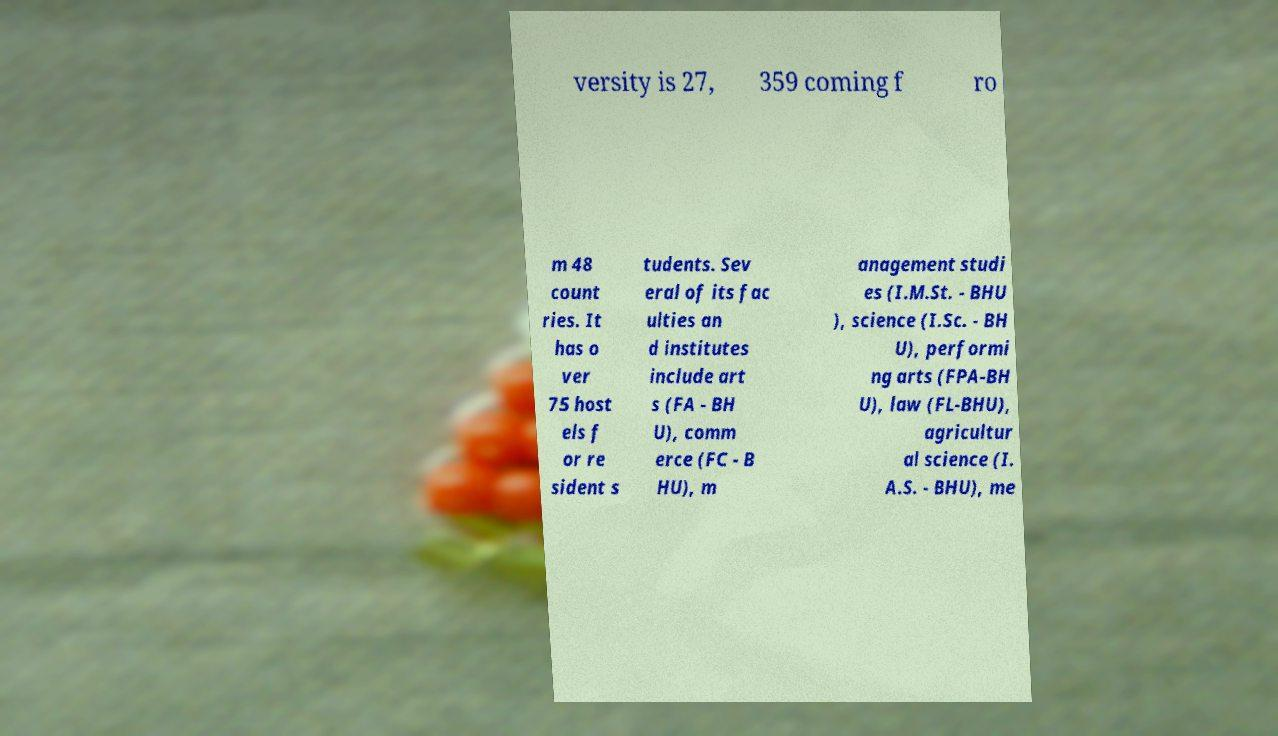Can you read and provide the text displayed in the image?This photo seems to have some interesting text. Can you extract and type it out for me? versity is 27, 359 coming f ro m 48 count ries. It has o ver 75 host els f or re sident s tudents. Sev eral of its fac ulties an d institutes include art s (FA - BH U), comm erce (FC - B HU), m anagement studi es (I.M.St. - BHU ), science (I.Sc. - BH U), performi ng arts (FPA-BH U), law (FL-BHU), agricultur al science (I. A.S. - BHU), me 